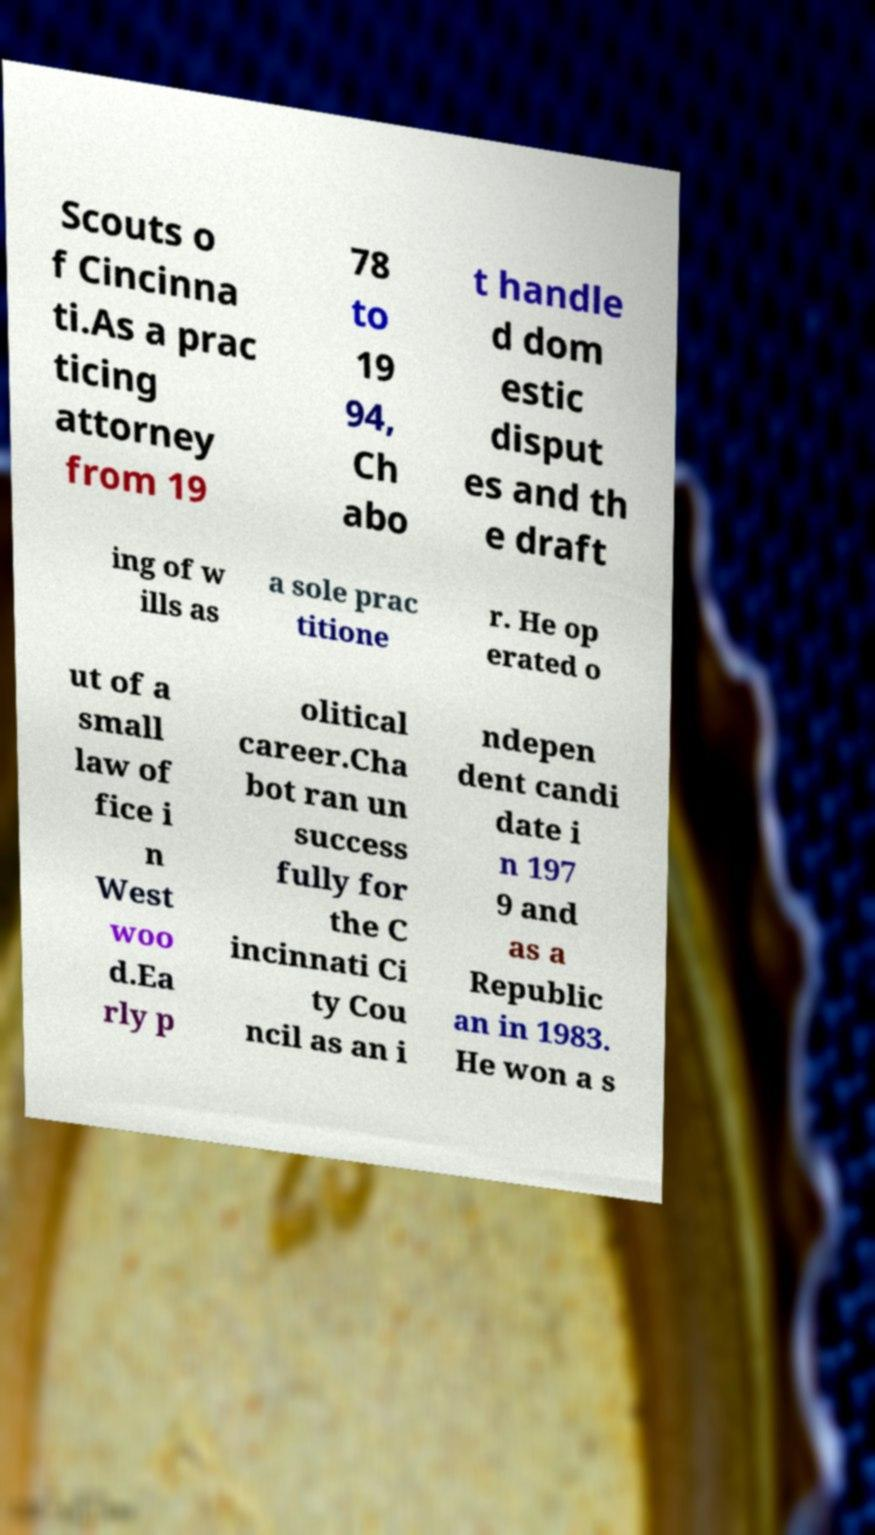Could you extract and type out the text from this image? Scouts o f Cincinna ti.As a prac ticing attorney from 19 78 to 19 94, Ch abo t handle d dom estic disput es and th e draft ing of w ills as a sole prac titione r. He op erated o ut of a small law of fice i n West woo d.Ea rly p olitical career.Cha bot ran un success fully for the C incinnati Ci ty Cou ncil as an i ndepen dent candi date i n 197 9 and as a Republic an in 1983. He won a s 